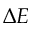Convert formula to latex. <formula><loc_0><loc_0><loc_500><loc_500>\Delta E</formula> 